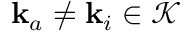Convert formula to latex. <formula><loc_0><loc_0><loc_500><loc_500>k _ { a } \neq k _ { i } \in \mathcal { K }</formula> 